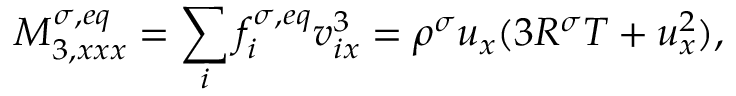<formula> <loc_0><loc_0><loc_500><loc_500>M _ { 3 , x x x } ^ { \sigma , e q } = \sum _ { i } f _ { i } ^ { \sigma , e q } v _ { i x } ^ { 3 } = \rho ^ { \sigma } u _ { x } ( 3 R ^ { \sigma } T + u _ { x } ^ { 2 } ) ,</formula> 